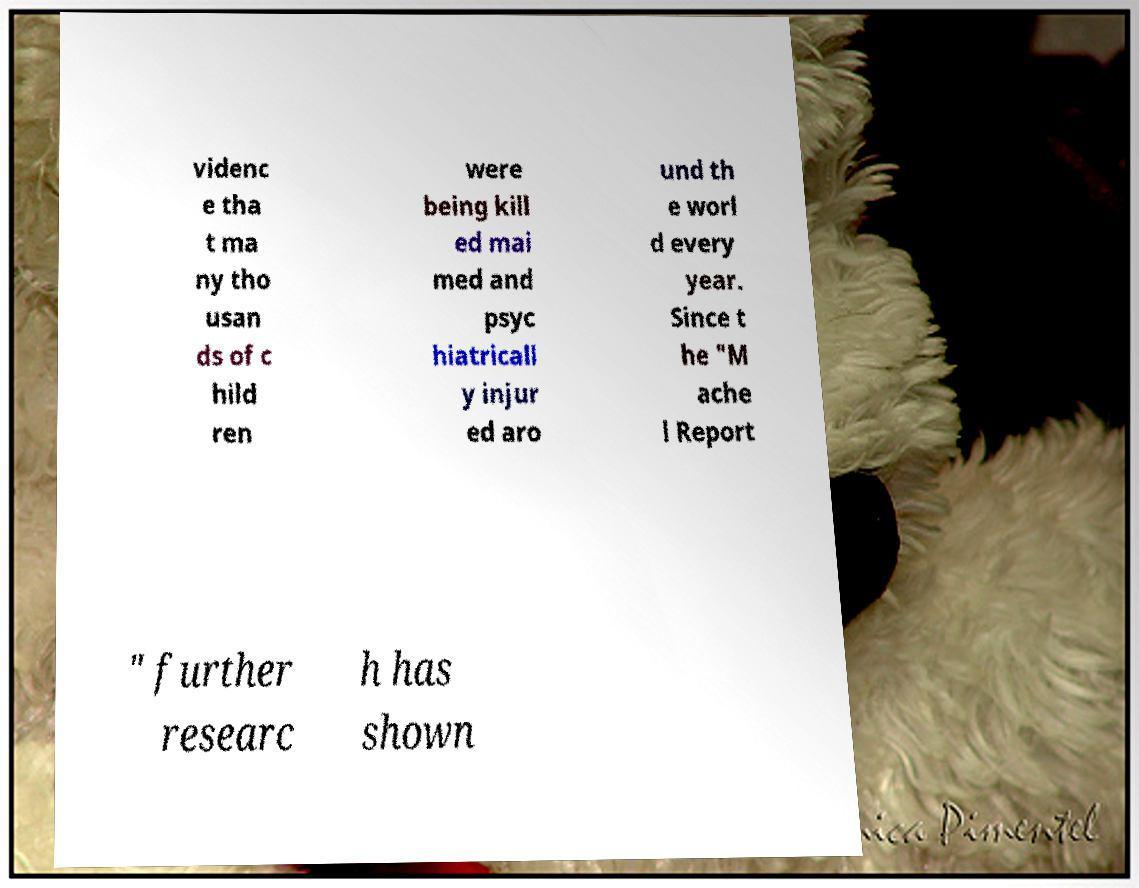What messages or text are displayed in this image? I need them in a readable, typed format. videnc e tha t ma ny tho usan ds of c hild ren were being kill ed mai med and psyc hiatricall y injur ed aro und th e worl d every year. Since t he "M ache l Report " further researc h has shown 